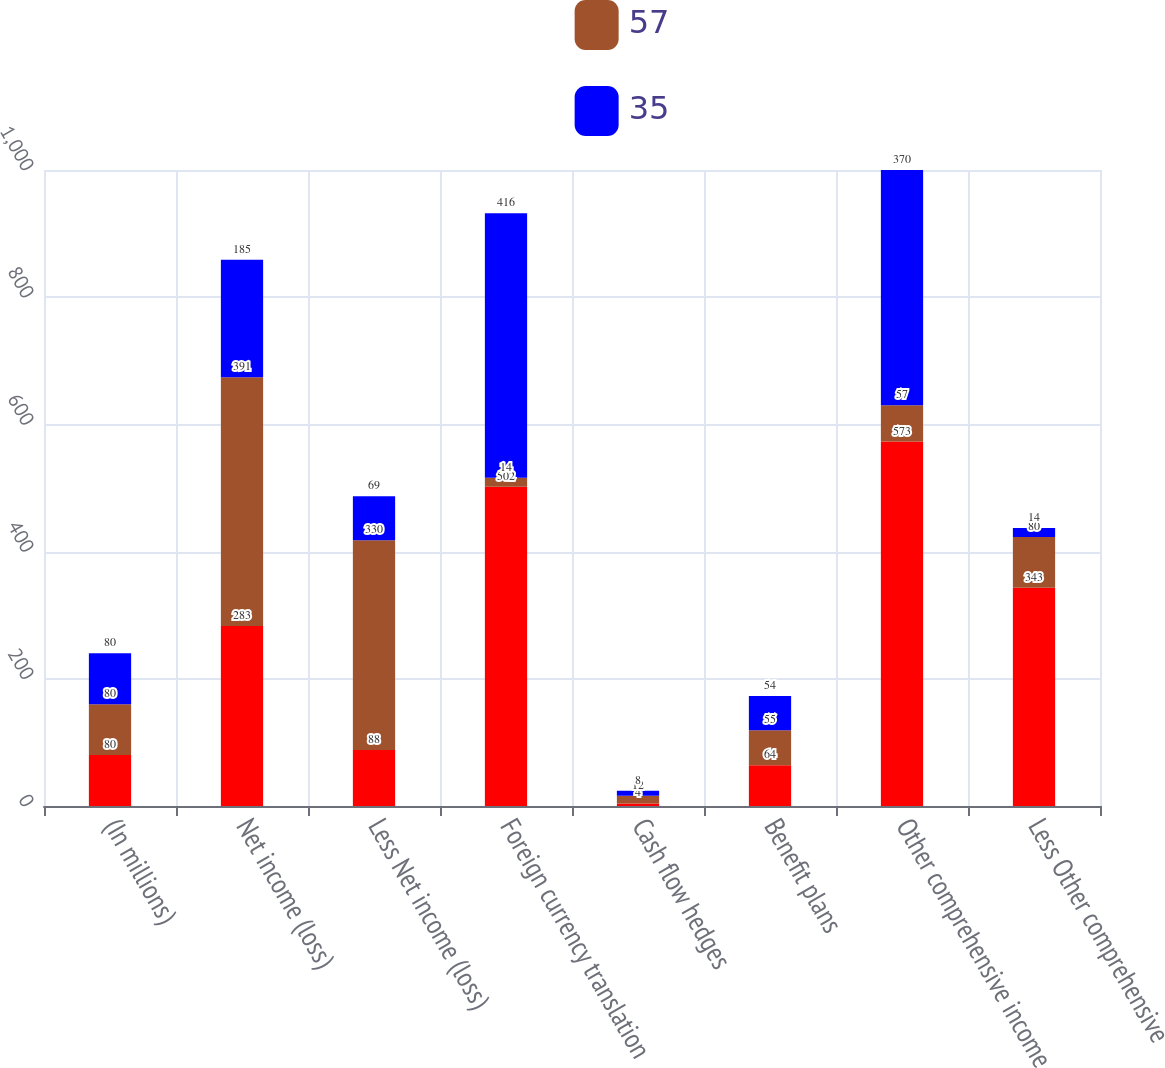<chart> <loc_0><loc_0><loc_500><loc_500><stacked_bar_chart><ecel><fcel>(In millions)<fcel>Net income (loss)<fcel>Less Net income (loss)<fcel>Foreign currency translation<fcel>Cash flow hedges<fcel>Benefit plans<fcel>Other comprehensive income<fcel>Less Other comprehensive<nl><fcel>nan<fcel>80<fcel>283<fcel>88<fcel>502<fcel>4<fcel>64<fcel>573<fcel>343<nl><fcel>57<fcel>80<fcel>391<fcel>330<fcel>14<fcel>12<fcel>55<fcel>57<fcel>80<nl><fcel>35<fcel>80<fcel>185<fcel>69<fcel>416<fcel>8<fcel>54<fcel>370<fcel>14<nl></chart> 